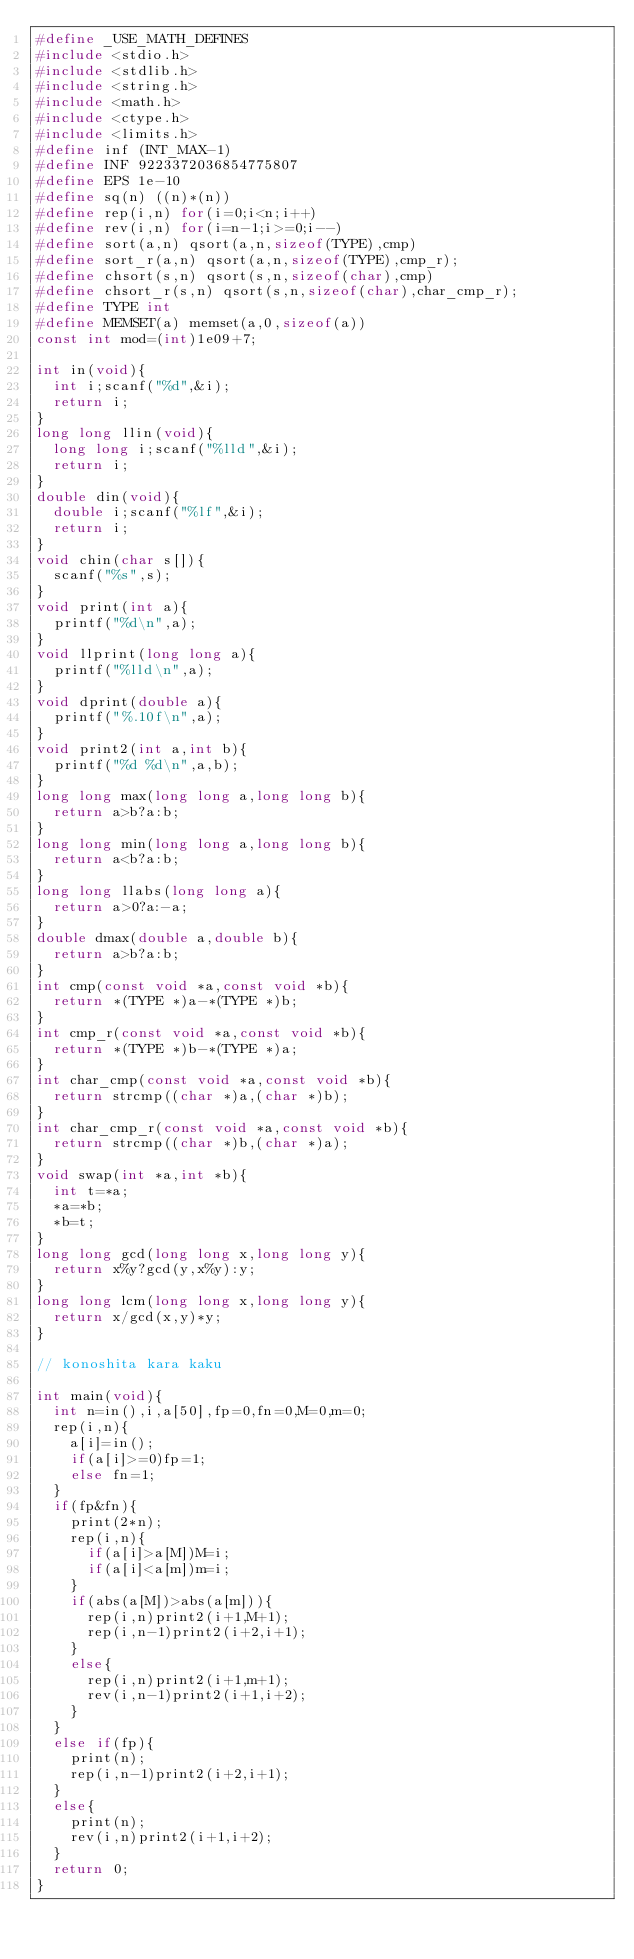Convert code to text. <code><loc_0><loc_0><loc_500><loc_500><_C_>#define _USE_MATH_DEFINES
#include <stdio.h>
#include <stdlib.h>
#include <string.h>
#include <math.h>
#include <ctype.h>
#include <limits.h>	
#define inf (INT_MAX-1)
#define INF 9223372036854775807
#define EPS 1e-10
#define sq(n) ((n)*(n))
#define rep(i,n) for(i=0;i<n;i++)
#define rev(i,n) for(i=n-1;i>=0;i--)
#define sort(a,n) qsort(a,n,sizeof(TYPE),cmp)
#define sort_r(a,n) qsort(a,n,sizeof(TYPE),cmp_r);
#define chsort(s,n) qsort(s,n,sizeof(char),cmp)
#define chsort_r(s,n) qsort(s,n,sizeof(char),char_cmp_r);
#define TYPE int
#define MEMSET(a) memset(a,0,sizeof(a))
const int mod=(int)1e09+7;

int in(void){
	int i;scanf("%d",&i);
	return i;
}
long long llin(void){
	long long i;scanf("%lld",&i);
	return i;
}
double din(void){
	double i;scanf("%lf",&i);
	return i;
}
void chin(char s[]){
	scanf("%s",s);
}
void print(int a){
	printf("%d\n",a);
}
void llprint(long long a){
	printf("%lld\n",a);
}
void dprint(double a){
	printf("%.10f\n",a);
}
void print2(int a,int b){
	printf("%d %d\n",a,b);
}
long long max(long long a,long long b){
	return a>b?a:b;
}
long long min(long long a,long long b){
	return a<b?a:b;
}
long long llabs(long long a){
	return a>0?a:-a;
}
double dmax(double a,double b){
	return a>b?a:b;
}
int cmp(const void *a,const void *b){
	return *(TYPE *)a-*(TYPE *)b;
}
int cmp_r(const void *a,const void *b){
	return *(TYPE *)b-*(TYPE *)a;
}
int char_cmp(const void *a,const void *b){
	return strcmp((char *)a,(char *)b);
}
int char_cmp_r(const void *a,const void *b){
	return strcmp((char *)b,(char *)a);
}
void swap(int *a,int *b){
	int t=*a;
	*a=*b;
	*b=t;
}
long long gcd(long long x,long long y){
	return x%y?gcd(y,x%y):y;
}
long long lcm(long long x,long long y){
	return x/gcd(x,y)*y;
}

// konoshita kara kaku

int main(void){
	int n=in(),i,a[50],fp=0,fn=0,M=0,m=0;
	rep(i,n){
		a[i]=in();
		if(a[i]>=0)fp=1;
		else fn=1;
	}
	if(fp&fn){
		print(2*n);
		rep(i,n){
			if(a[i]>a[M])M=i;
			if(a[i]<a[m])m=i;
		}
		if(abs(a[M])>abs(a[m])){
			rep(i,n)print2(i+1,M+1);
			rep(i,n-1)print2(i+2,i+1);
		}
		else{
			rep(i,n)print2(i+1,m+1);
			rev(i,n-1)print2(i+1,i+2);
		}
	}
	else if(fp){
		print(n);
		rep(i,n-1)print2(i+2,i+1);
	}
	else{
		print(n);
		rev(i,n)print2(i+1,i+2);
	}
	return 0;
}</code> 